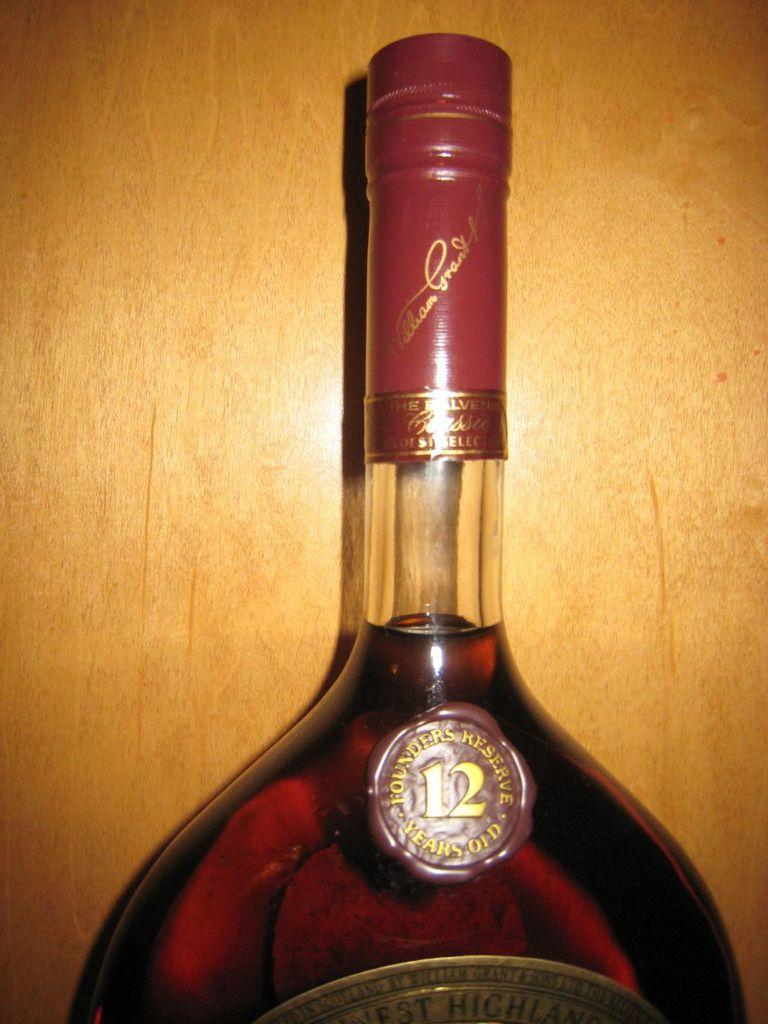What object can be seen in the image? There is a bottle in the image. What is inside the bottle? The bottle contains a liquid. What information is provided on the bottle? The bottle is labelled as 'founders'. Can you see any bones sticking out of the bottle in the image? No, there are no bones visible in the image. 